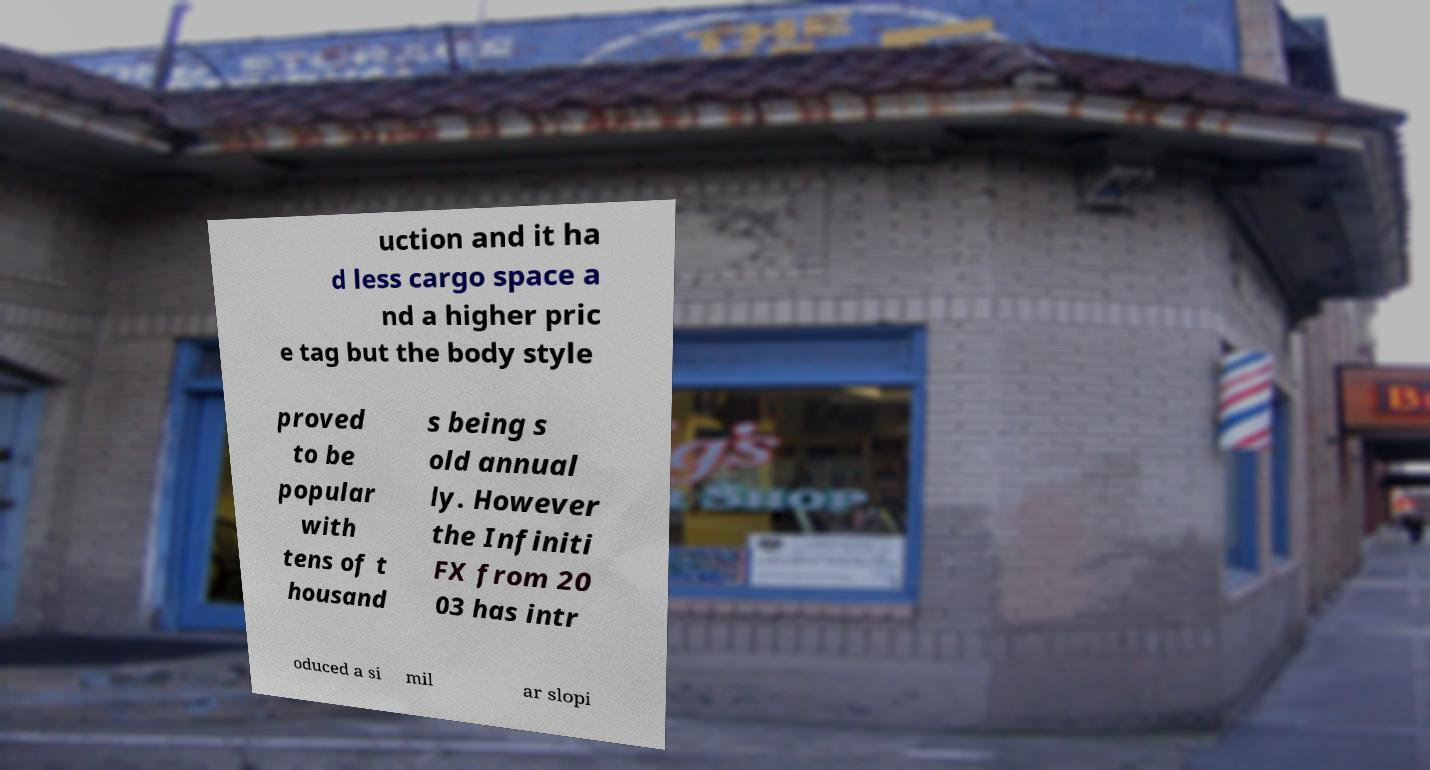Could you assist in decoding the text presented in this image and type it out clearly? uction and it ha d less cargo space a nd a higher pric e tag but the body style proved to be popular with tens of t housand s being s old annual ly. However the Infiniti FX from 20 03 has intr oduced a si mil ar slopi 